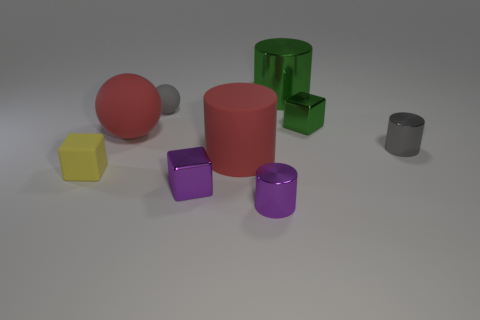Is the large sphere made of the same material as the block that is right of the small purple metallic cube?
Your response must be concise. No. Is there a matte ball that is on the right side of the rubber ball on the left side of the tiny object behind the tiny green shiny thing?
Your answer should be compact. Yes. Is there anything else that is the same size as the green metallic cube?
Provide a succinct answer. Yes. What color is the big cylinder that is made of the same material as the tiny yellow object?
Make the answer very short. Red. There is a object that is both to the left of the large shiny cylinder and behind the red sphere; how big is it?
Ensure brevity in your answer.  Small. Is the number of small metallic cubes that are to the left of the small green thing less than the number of big red rubber balls that are to the right of the red ball?
Your answer should be very brief. No. Do the block in front of the yellow object and the gray object to the left of the green shiny cylinder have the same material?
Offer a terse response. No. What material is the cylinder that is the same color as the small ball?
Your answer should be very brief. Metal. There is a tiny thing that is both behind the gray shiny cylinder and to the right of the red cylinder; what shape is it?
Offer a terse response. Cube. There is a small gray object that is behind the tiny metal cylinder on the right side of the tiny purple metallic cylinder; what is it made of?
Your answer should be very brief. Rubber. 